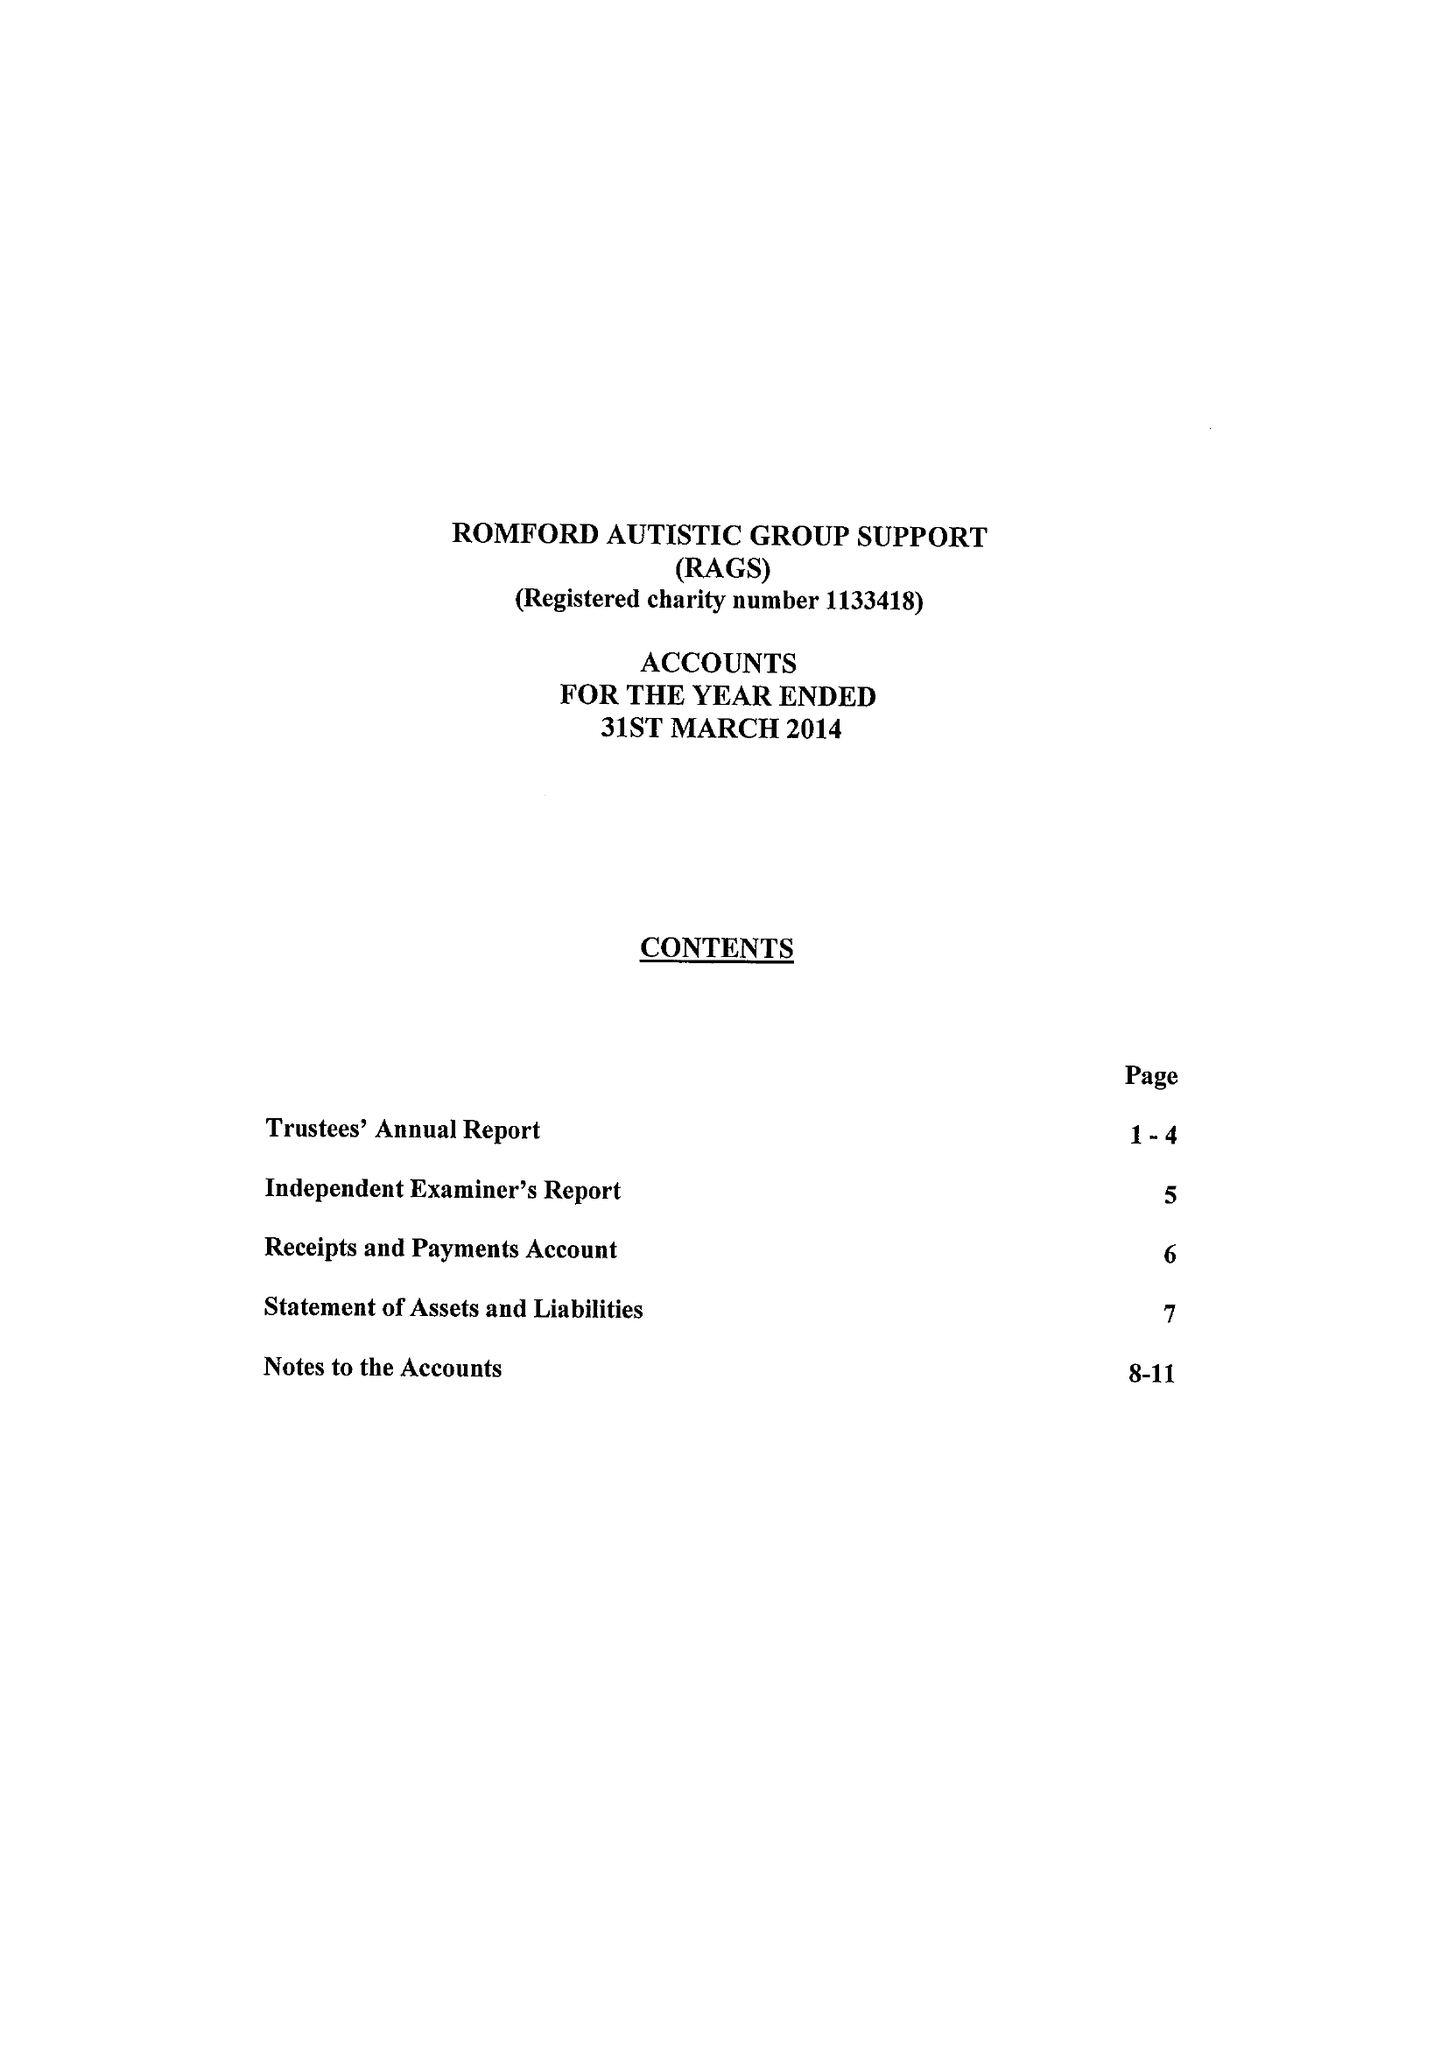What is the value for the address__postcode?
Answer the question using a single word or phrase. RM3 7SU 